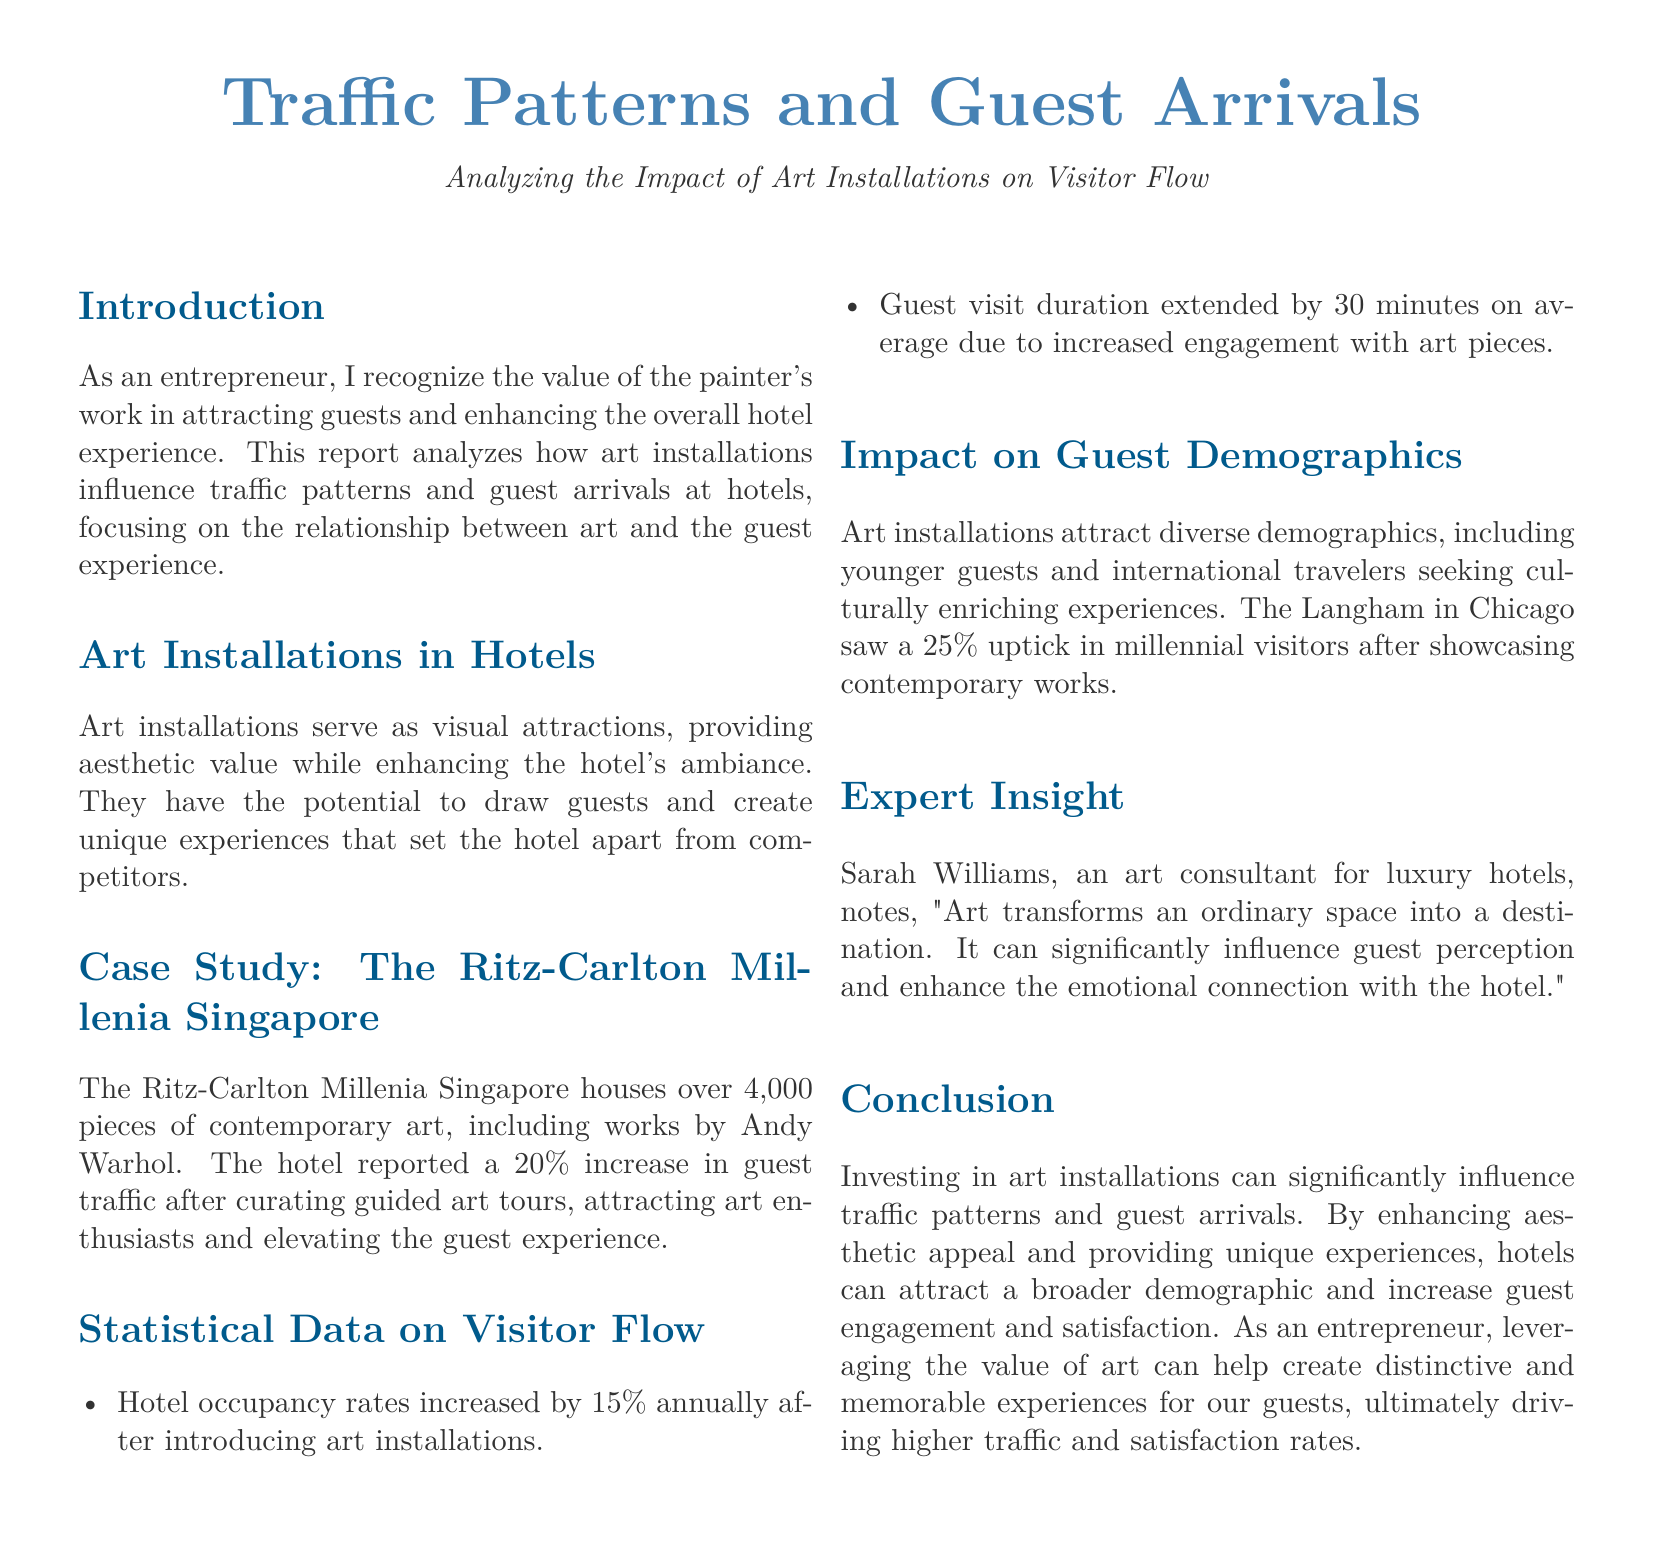What is the main focus of the report? The report analyzes how art installations influence traffic patterns and guest arrivals at hotels.
Answer: art installations influence traffic patterns and guest arrivals What percentage increase in guest traffic did The Ritz-Carlton Millenia Singapore report? The report states that the hotel reported a 20% increase in guest traffic after curating guided art tours.
Answer: 20% What is the average duration extension of guest visits due to art engagement? The document mentions that guest visit duration extended by 30 minutes on average due to increased engagement with art pieces.
Answer: 30 minutes Which hotel saw a 25% increase in millennial visitors? The Langham in Chicago is mentioned as having seen a 25% uptick in millennial visitors after showcasing contemporary works.
Answer: The Langham in Chicago Who provided insight into the impact of art on hotel experiences? Sarah Williams is noted as the art consultant for luxury hotels who provided insight in the report.
Answer: Sarah Williams What type of demographic do art installations attract according to the report? The report indicates that art installations attract diverse demographics, including younger guests and international travelers.
Answer: diverse demographics, younger guests, international travelers What aspect of hotels does the report emphasize as being transformed by art? The report states that art transforms an ordinary space into a destination.
Answer: ordinary space into a destination What percentage increase in hotel occupancy rates is reported after introducing art installations? The document states that hotel occupancy rates increased by 15% annually after introducing art installations.
Answer: 15% 